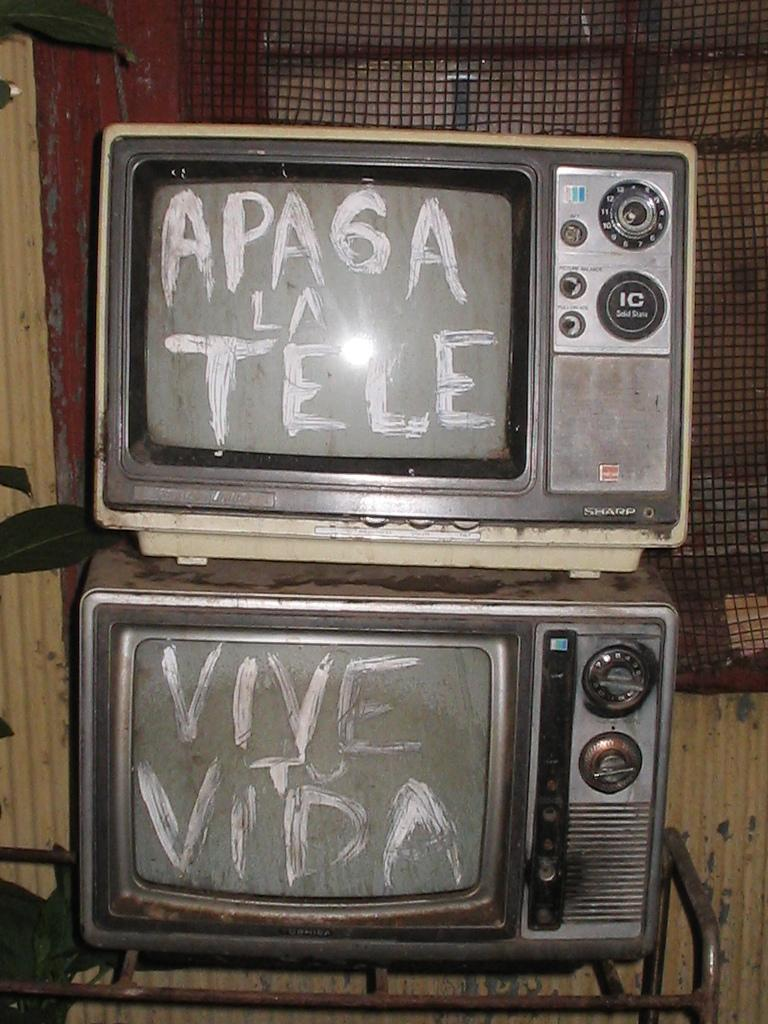<image>
Give a short and clear explanation of the subsequent image. Two television stacked on top of each other say Apaga La Tee Vive to Vida. 